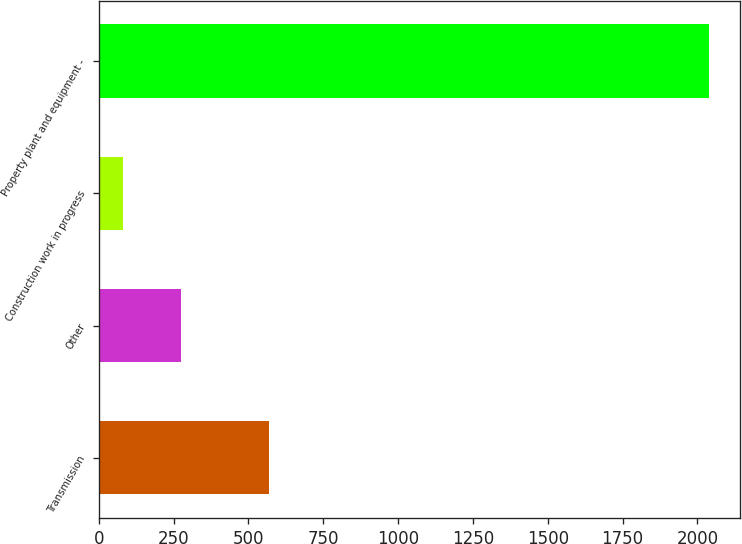<chart> <loc_0><loc_0><loc_500><loc_500><bar_chart><fcel>Transmission<fcel>Other<fcel>Construction work in progress<fcel>Property plant and equipment -<nl><fcel>569<fcel>276<fcel>80<fcel>2040<nl></chart> 